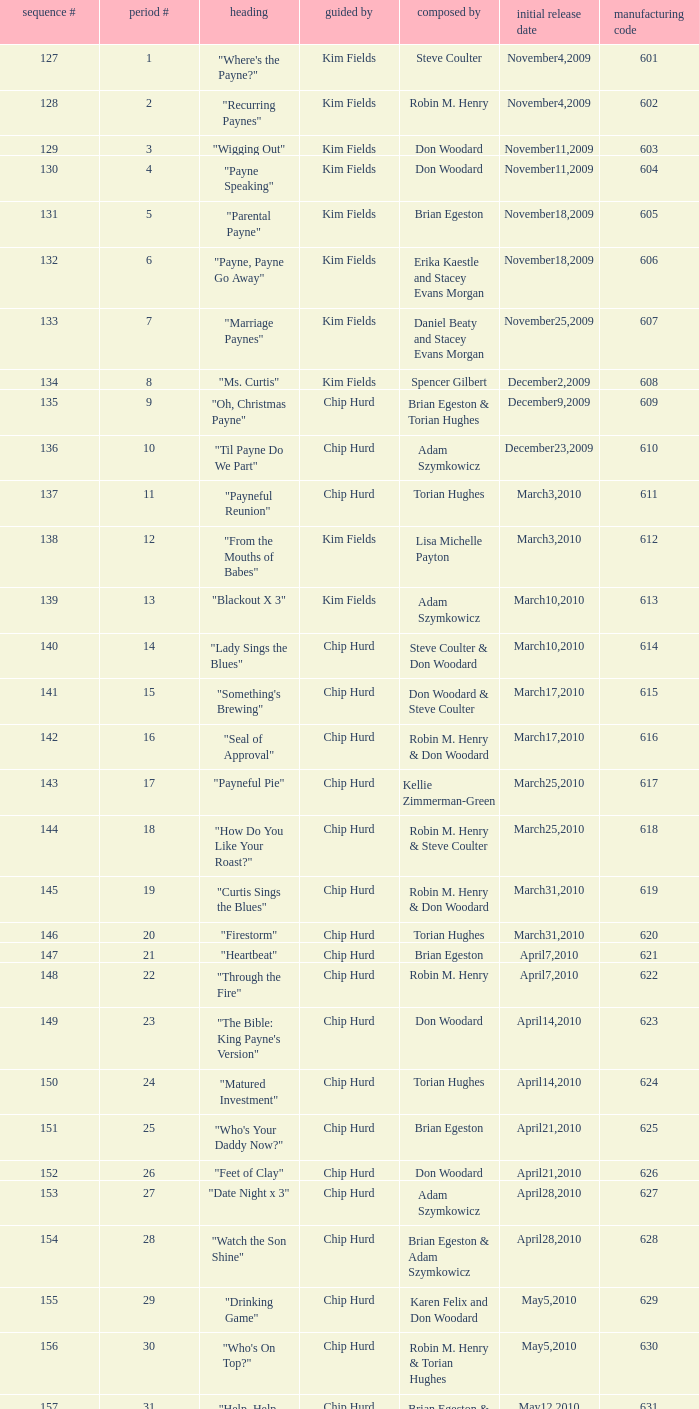What is the title of the episode with the production code 624? "Matured Investment". 